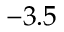Convert formula to latex. <formula><loc_0><loc_0><loc_500><loc_500>- 3 . 5</formula> 